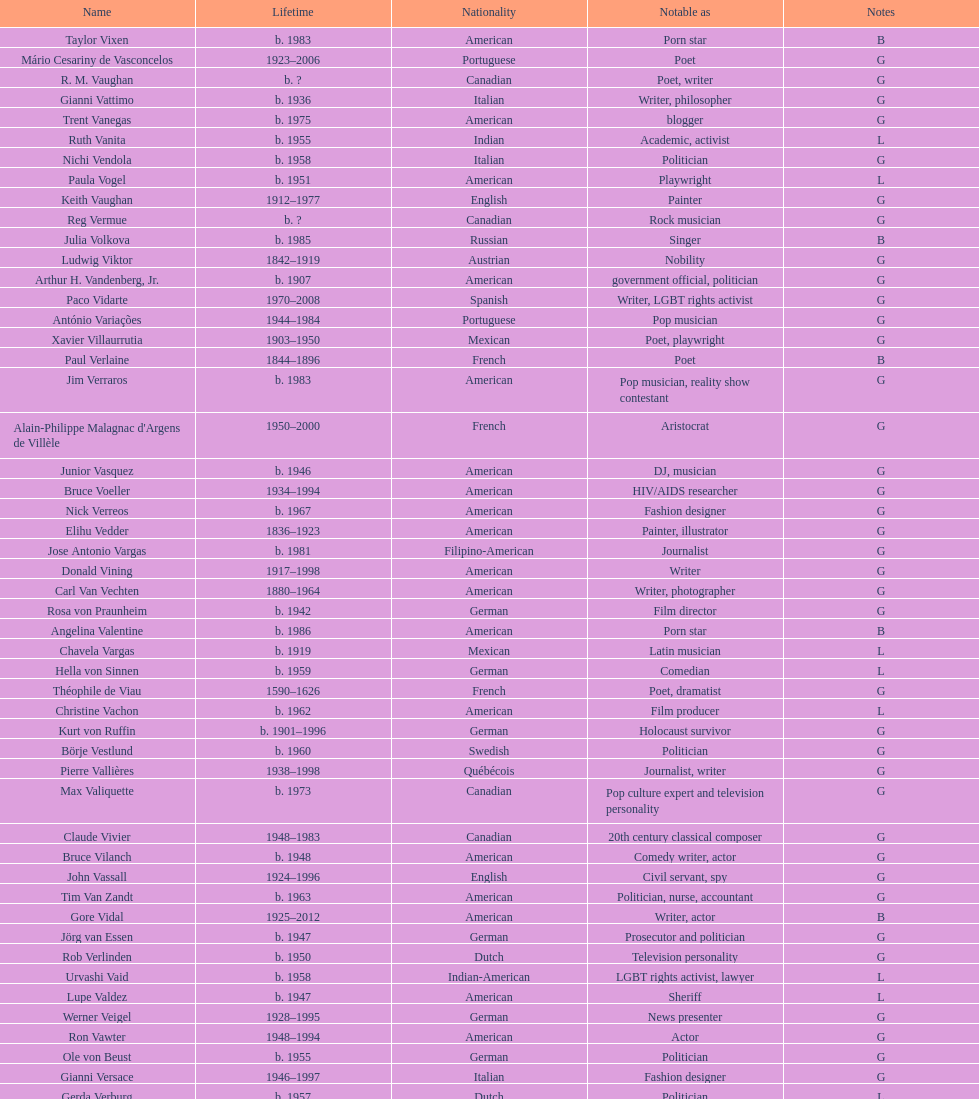What is the number of individuals in this group who were indian? 1. 